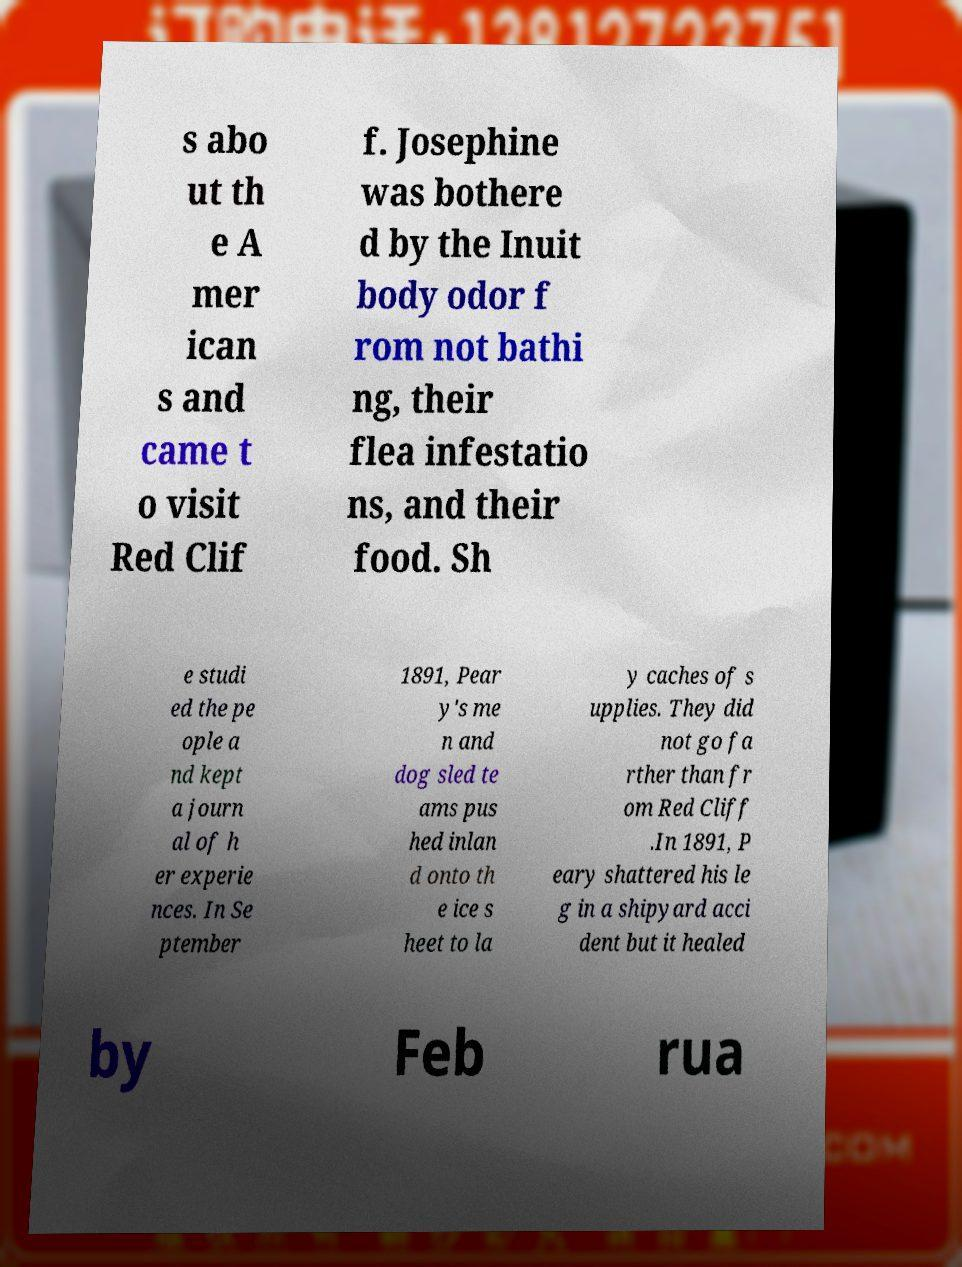Please read and relay the text visible in this image. What does it say? s abo ut th e A mer ican s and came t o visit Red Clif f. Josephine was bothere d by the Inuit body odor f rom not bathi ng, their flea infestatio ns, and their food. Sh e studi ed the pe ople a nd kept a journ al of h er experie nces. In Se ptember 1891, Pear y's me n and dog sled te ams pus hed inlan d onto th e ice s heet to la y caches of s upplies. They did not go fa rther than fr om Red Cliff .In 1891, P eary shattered his le g in a shipyard acci dent but it healed by Feb rua 